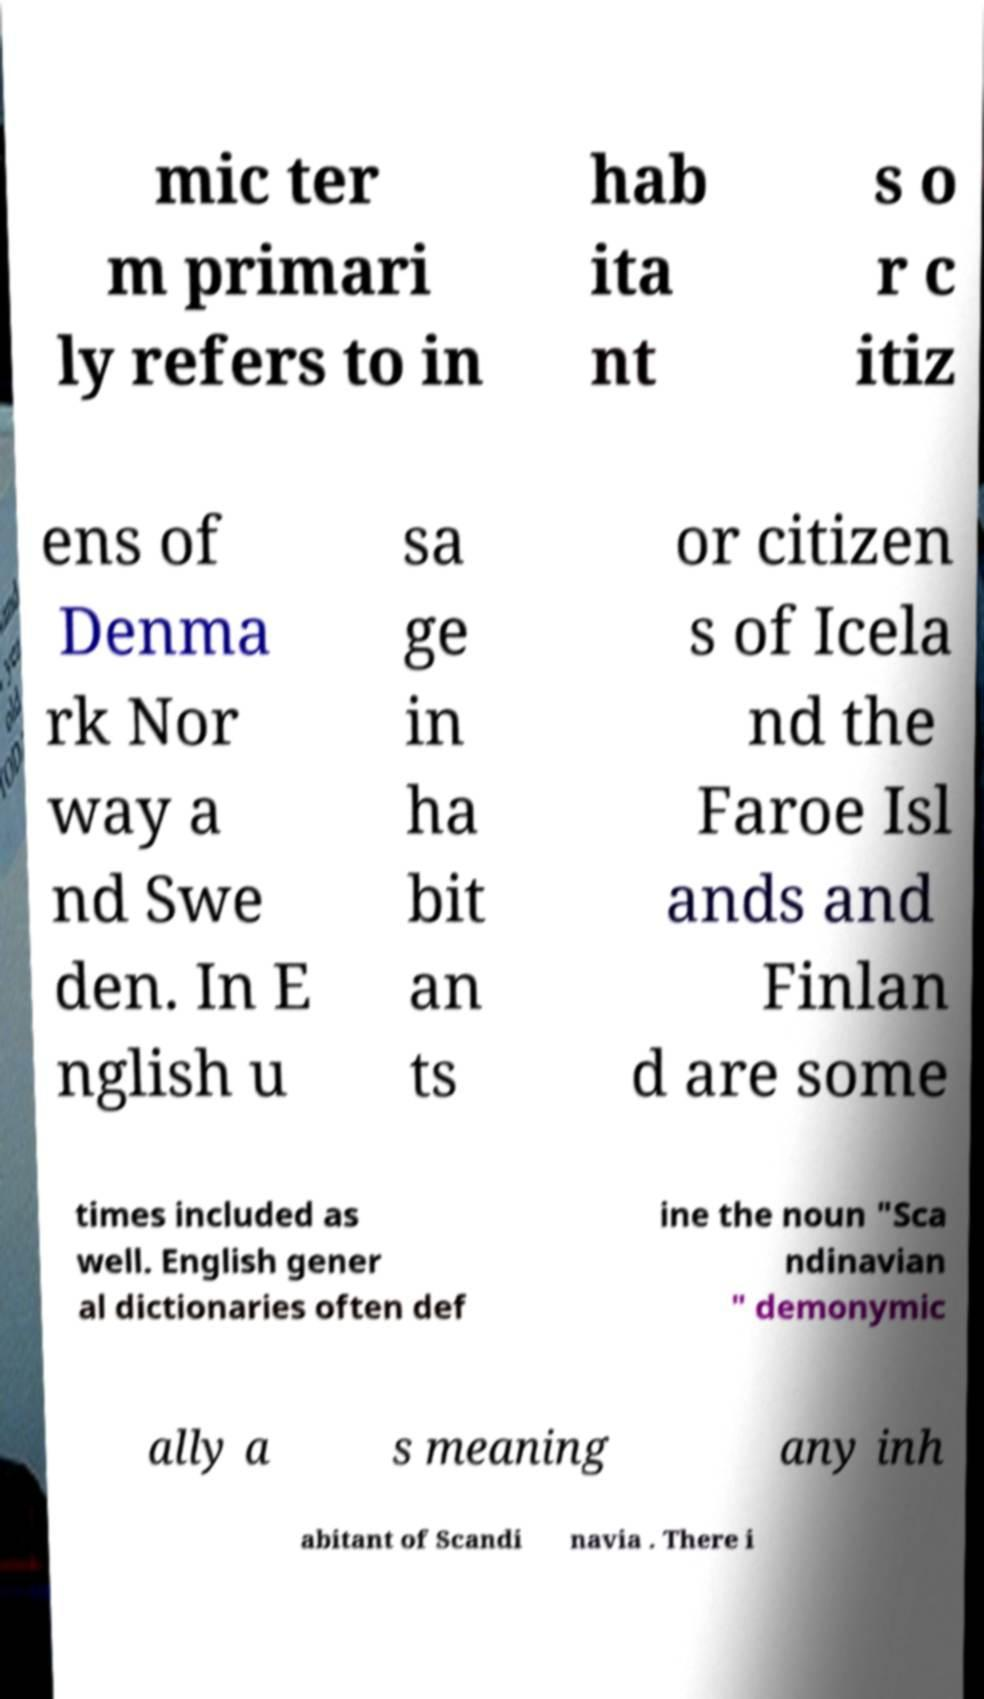Could you extract and type out the text from this image? mic ter m primari ly refers to in hab ita nt s o r c itiz ens of Denma rk Nor way a nd Swe den. In E nglish u sa ge in ha bit an ts or citizen s of Icela nd the Faroe Isl ands and Finlan d are some times included as well. English gener al dictionaries often def ine the noun "Sca ndinavian " demonymic ally a s meaning any inh abitant of Scandi navia . There i 